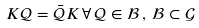Convert formula to latex. <formula><loc_0><loc_0><loc_500><loc_500>K \mathcal { Q } = \bar { \mathcal { Q } } K \, \forall \, \mathcal { Q } \in \mathcal { B } \, , \, \mathcal { B } \subset \mathcal { G }</formula> 